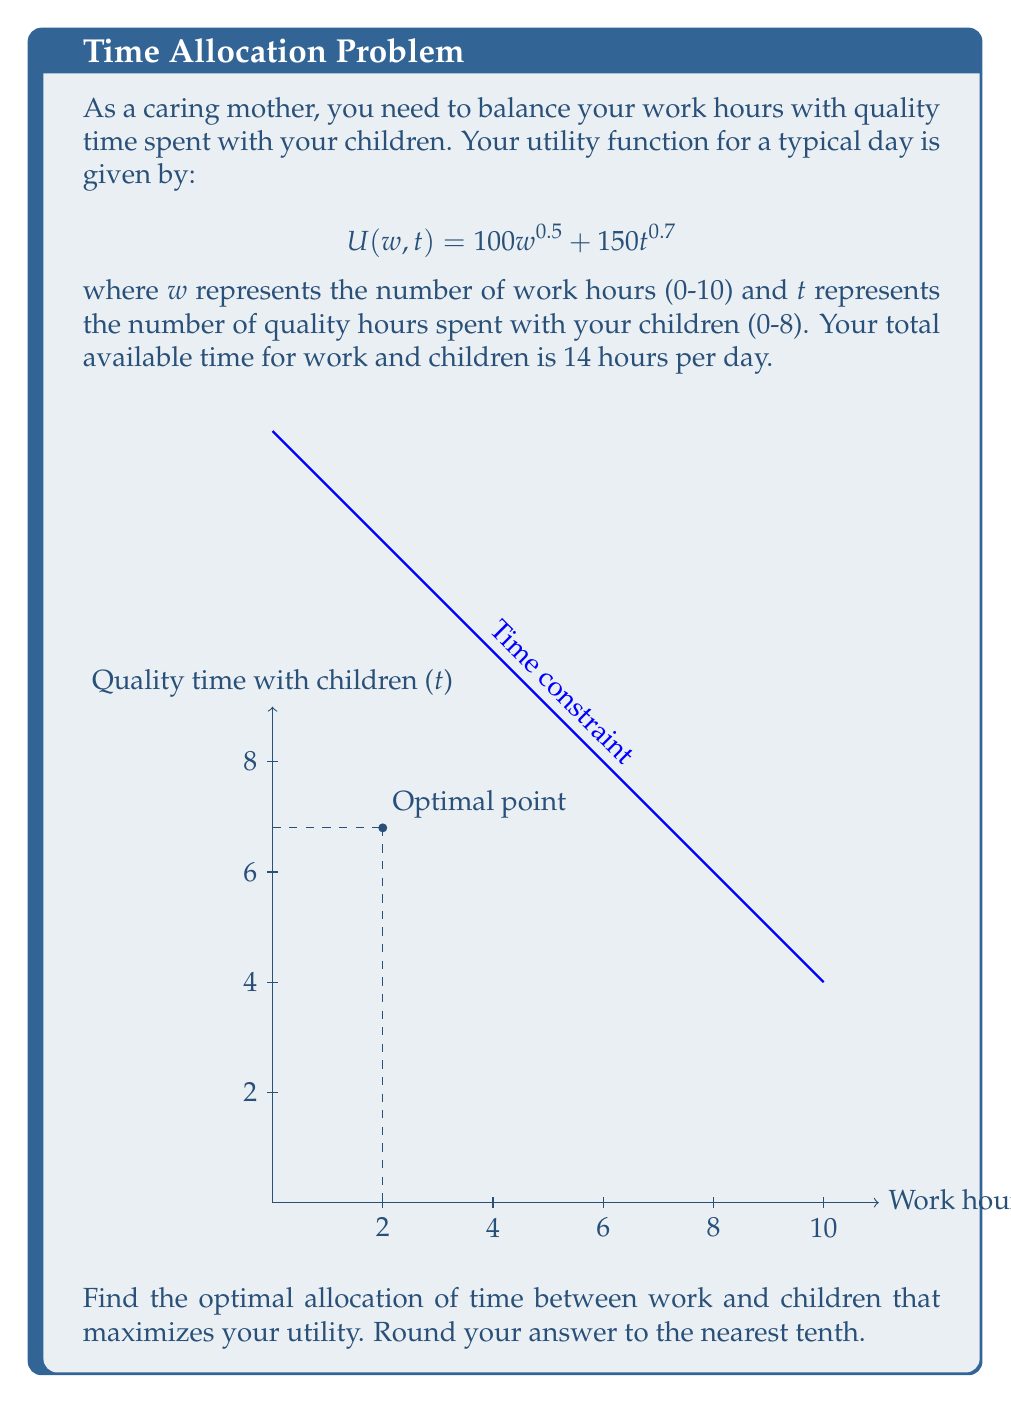Teach me how to tackle this problem. Let's approach this step-by-step:

1) First, we need to express $t$ in terms of $w$ given the time constraint:
   $w + t = 14$, so $t = 14 - w$

2) Now we can rewrite the utility function in terms of $w$ only:
   $$U(w) = 100w^{0.5} + 150(14-w)^{0.7}$$

3) To find the maximum, we differentiate $U(w)$ with respect to $w$ and set it to zero:
   $$\frac{dU}{dw} = 50w^{-0.5} - 105(14-w)^{-0.3} = 0$$

4) This equation can't be solved algebraically, so we need to use numerical methods. Using a calculator or computer, we find that the solution is approximately $w ≈ 2.0$.

5) Given $w ≈ 2.0$, we can find $t$:
   $t = 14 - 2.0 = 12.0$

6) However, we need to check if this solution respects the constraints (0 ≤ w ≤ 10 and 0 ≤ t ≤ 8).
   We see that $t > 8$, so this solution is not valid.

7) Given the constraint on $t$, the optimal solution must be at the boundary where $t = 8$.

8) If $t = 8$, then $w = 14 - 8 = 6$.

9) We can verify that this gives a higher utility than other boundary points:
   At $(w,t) = (6,8)$: $U = 100(6)^{0.5} + 150(8)^{0.7} ≈ 1310.7$
   At $(w,t) = (10,4)$: $U = 100(10)^{0.5} + 150(4)^{0.7} ≈ 1015.9$

Therefore, the optimal allocation is 6 hours of work and 8 hours of quality time with children.
Answer: $(w,t) = (6.0, 8.0)$ 